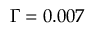Convert formula to latex. <formula><loc_0><loc_0><loc_500><loc_500>\Gamma = 0 . 0 0 7</formula> 